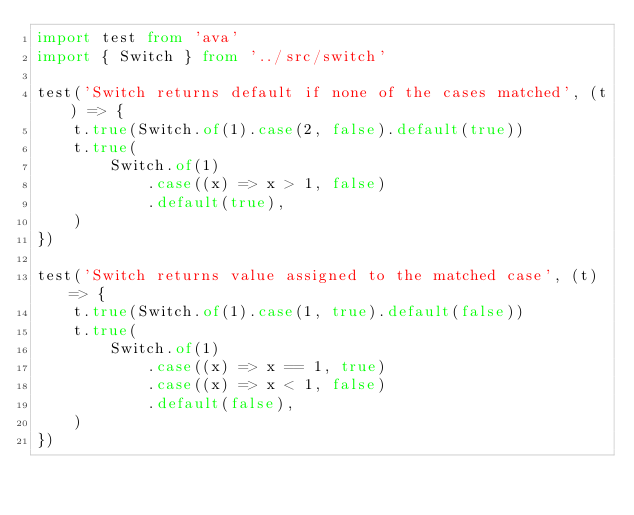<code> <loc_0><loc_0><loc_500><loc_500><_TypeScript_>import test from 'ava'
import { Switch } from '../src/switch'

test('Switch returns default if none of the cases matched', (t) => {
	t.true(Switch.of(1).case(2, false).default(true))
	t.true(
		Switch.of(1)
			.case((x) => x > 1, false)
			.default(true),
	)
})

test('Switch returns value assigned to the matched case', (t) => {
	t.true(Switch.of(1).case(1, true).default(false))
	t.true(
		Switch.of(1)
			.case((x) => x == 1, true)
			.case((x) => x < 1, false)
			.default(false),
	)
})
</code> 